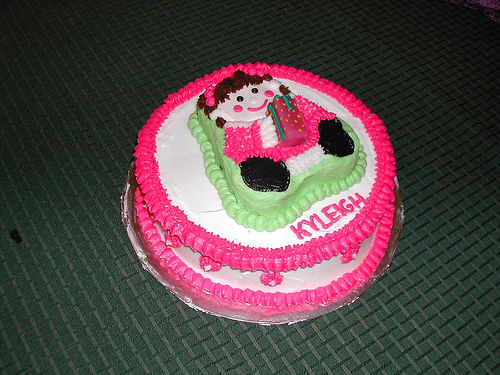<image>
Is the name on the cake? Yes. Looking at the image, I can see the name is positioned on top of the cake, with the cake providing support. Is there a cake in front of the table? No. The cake is not in front of the table. The spatial positioning shows a different relationship between these objects. 